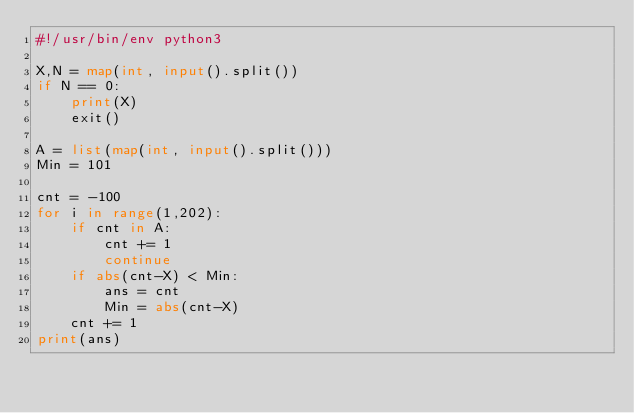Convert code to text. <code><loc_0><loc_0><loc_500><loc_500><_Python_>#!/usr/bin/env python3

X,N = map(int, input().split())
if N == 0:
    print(X)
    exit()

A = list(map(int, input().split()))
Min = 101

cnt = -100
for i in range(1,202):
    if cnt in A:
        cnt += 1
        continue
    if abs(cnt-X) < Min:
        ans = cnt
        Min = abs(cnt-X)
    cnt += 1
print(ans)</code> 